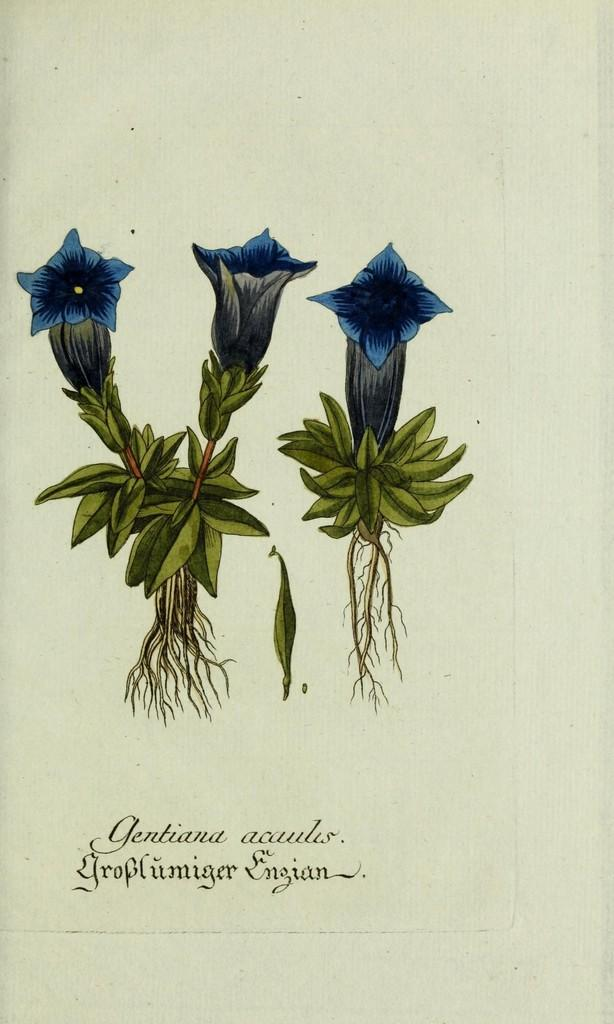What is the main subject of the image? The image contains an art piece. What is the theme or content of the art piece? The art piece depicts flowers and plants. Is there any text present in the image? Yes, there is some text present in the image. How many clouds can be seen in the art piece? There are no clouds depicted in the art piece; it features flowers and plants. Is there a shop visible in the image? There is no shop present in the image; it contains an art piece depicting flowers and plants. 